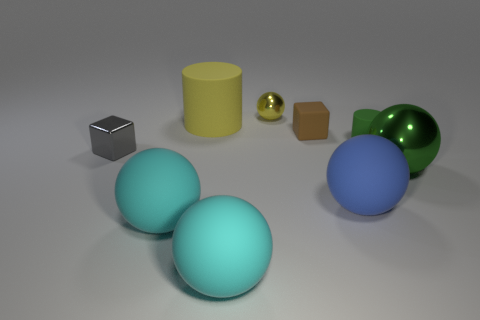Subtract all yellow balls. How many balls are left? 4 Subtract all small balls. How many balls are left? 4 Add 1 small metallic cylinders. How many objects exist? 10 Subtract all purple spheres. Subtract all blue cubes. How many spheres are left? 5 Subtract all cubes. How many objects are left? 7 Add 2 small purple metallic things. How many small purple metallic things exist? 2 Subtract 0 green cubes. How many objects are left? 9 Subtract all yellow metallic objects. Subtract all large matte things. How many objects are left? 4 Add 4 large spheres. How many large spheres are left? 8 